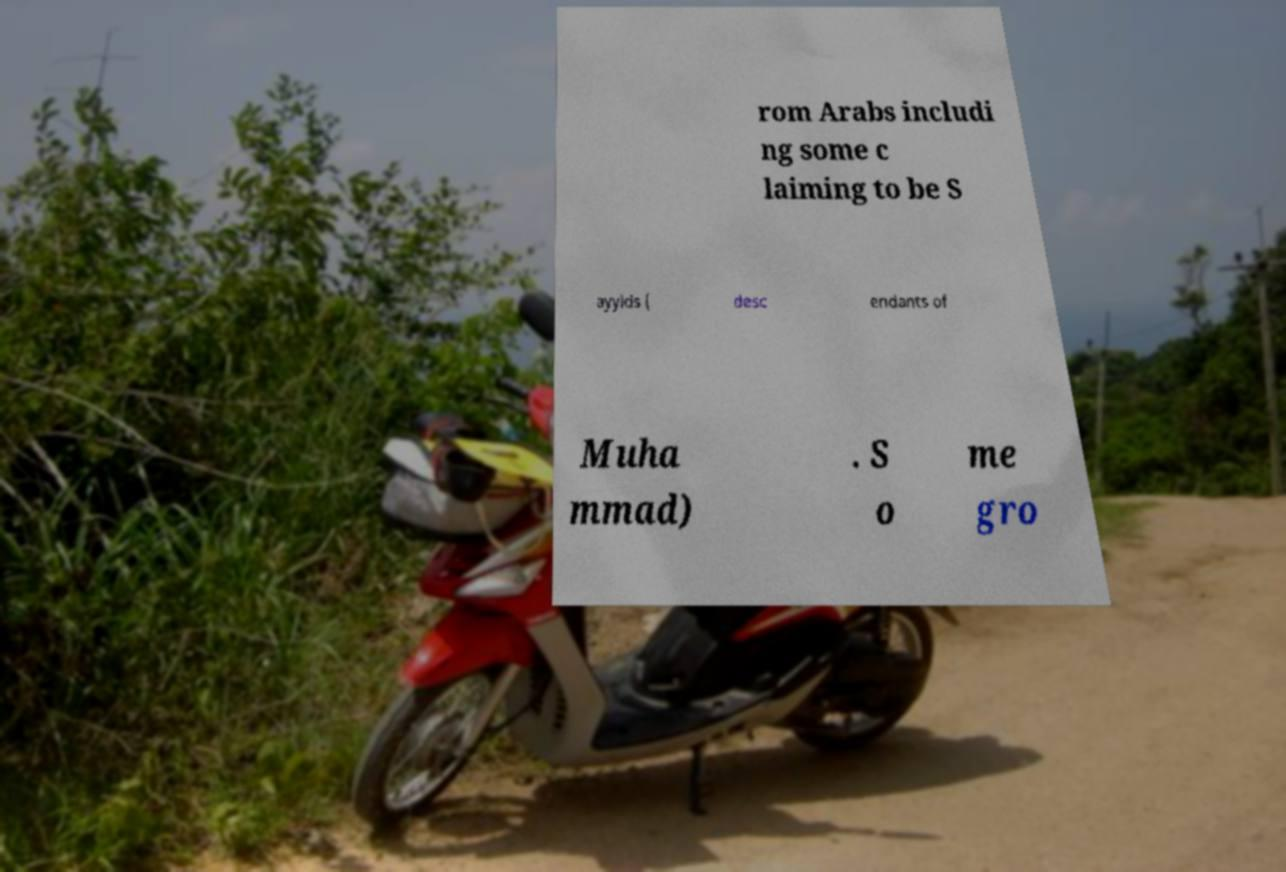Please identify and transcribe the text found in this image. rom Arabs includi ng some c laiming to be S ayyids ( desc endants of Muha mmad) . S o me gro 